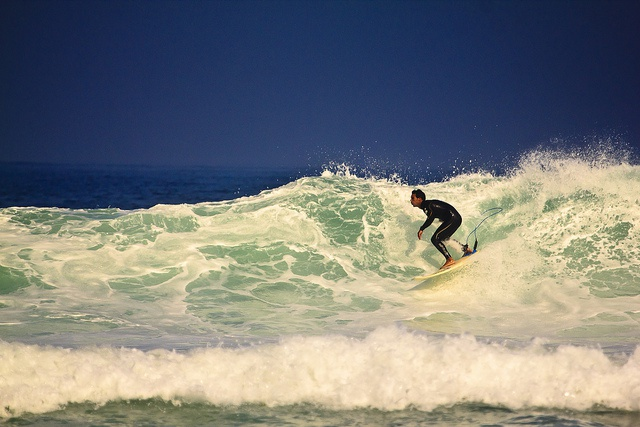Describe the objects in this image and their specific colors. I can see people in black, maroon, gray, and tan tones and surfboard in black, khaki, and tan tones in this image. 